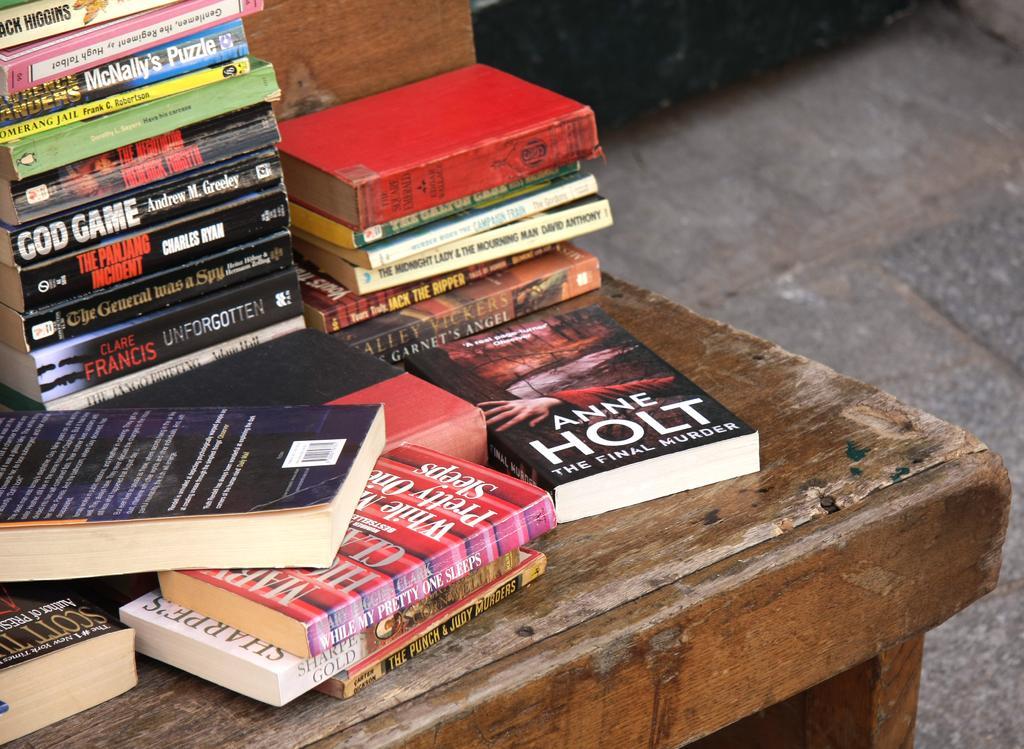In one or two sentences, can you explain what this image depicts? This image consists of books kept on a wooden table. At the bottom, there is a floor. 